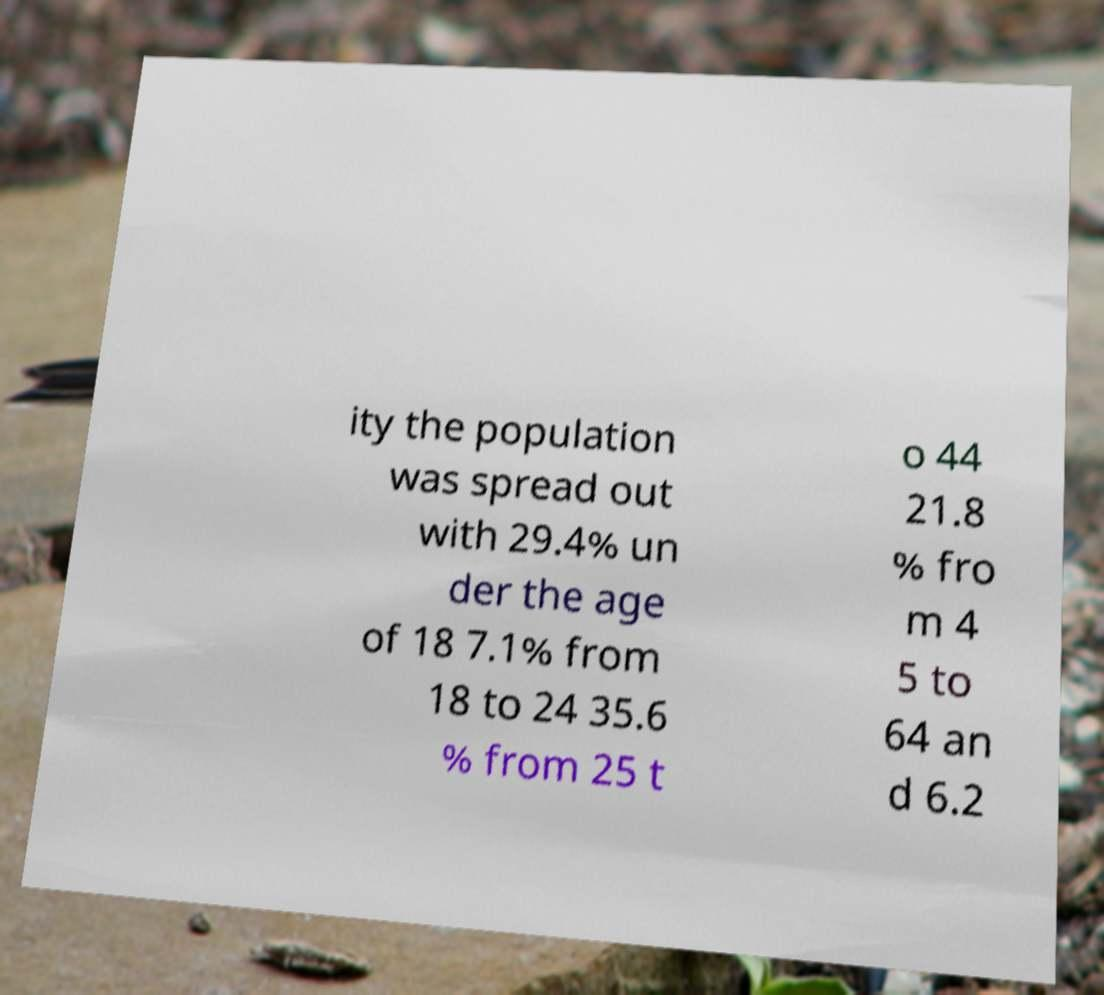There's text embedded in this image that I need extracted. Can you transcribe it verbatim? ity the population was spread out with 29.4% un der the age of 18 7.1% from 18 to 24 35.6 % from 25 t o 44 21.8 % fro m 4 5 to 64 an d 6.2 